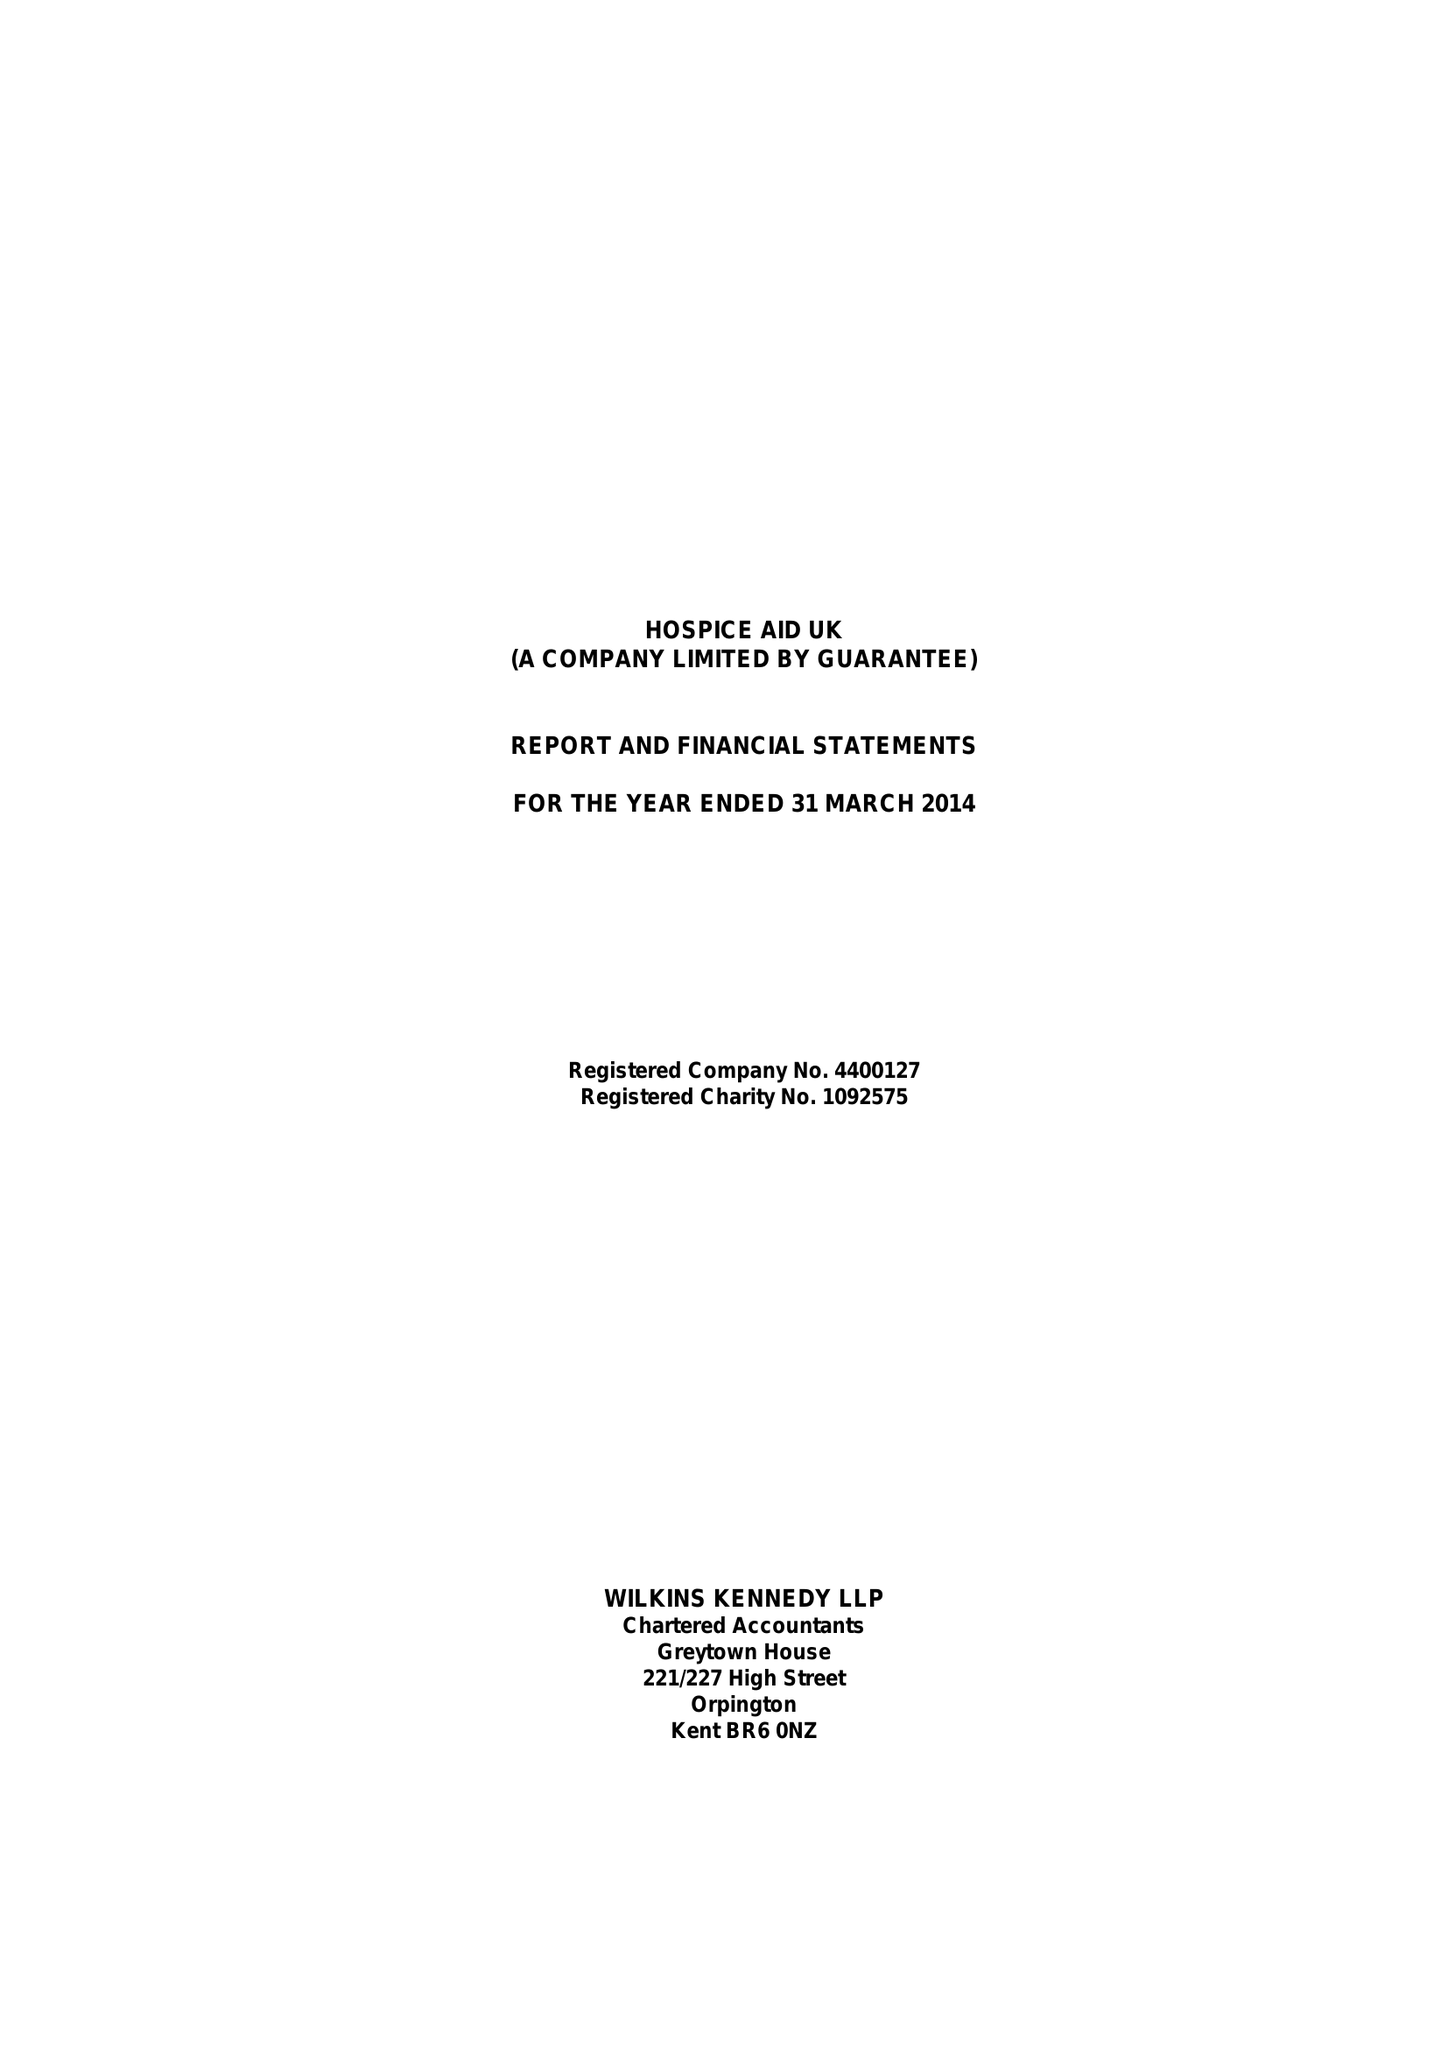What is the value for the spending_annually_in_british_pounds?
Answer the question using a single word or phrase. 582432.00 